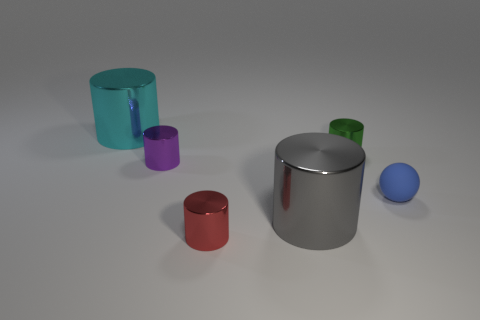Subtract all green cylinders. How many cylinders are left? 4 Subtract 1 cylinders. How many cylinders are left? 4 Subtract all big gray cylinders. How many cylinders are left? 4 Add 1 green metal cylinders. How many objects exist? 7 Subtract all gray cylinders. Subtract all yellow balls. How many cylinders are left? 4 Subtract all spheres. How many objects are left? 5 Subtract all purple metal cylinders. Subtract all rubber spheres. How many objects are left? 4 Add 1 tiny matte objects. How many tiny matte objects are left? 2 Add 4 small cyan shiny cylinders. How many small cyan shiny cylinders exist? 4 Subtract 0 cyan blocks. How many objects are left? 6 